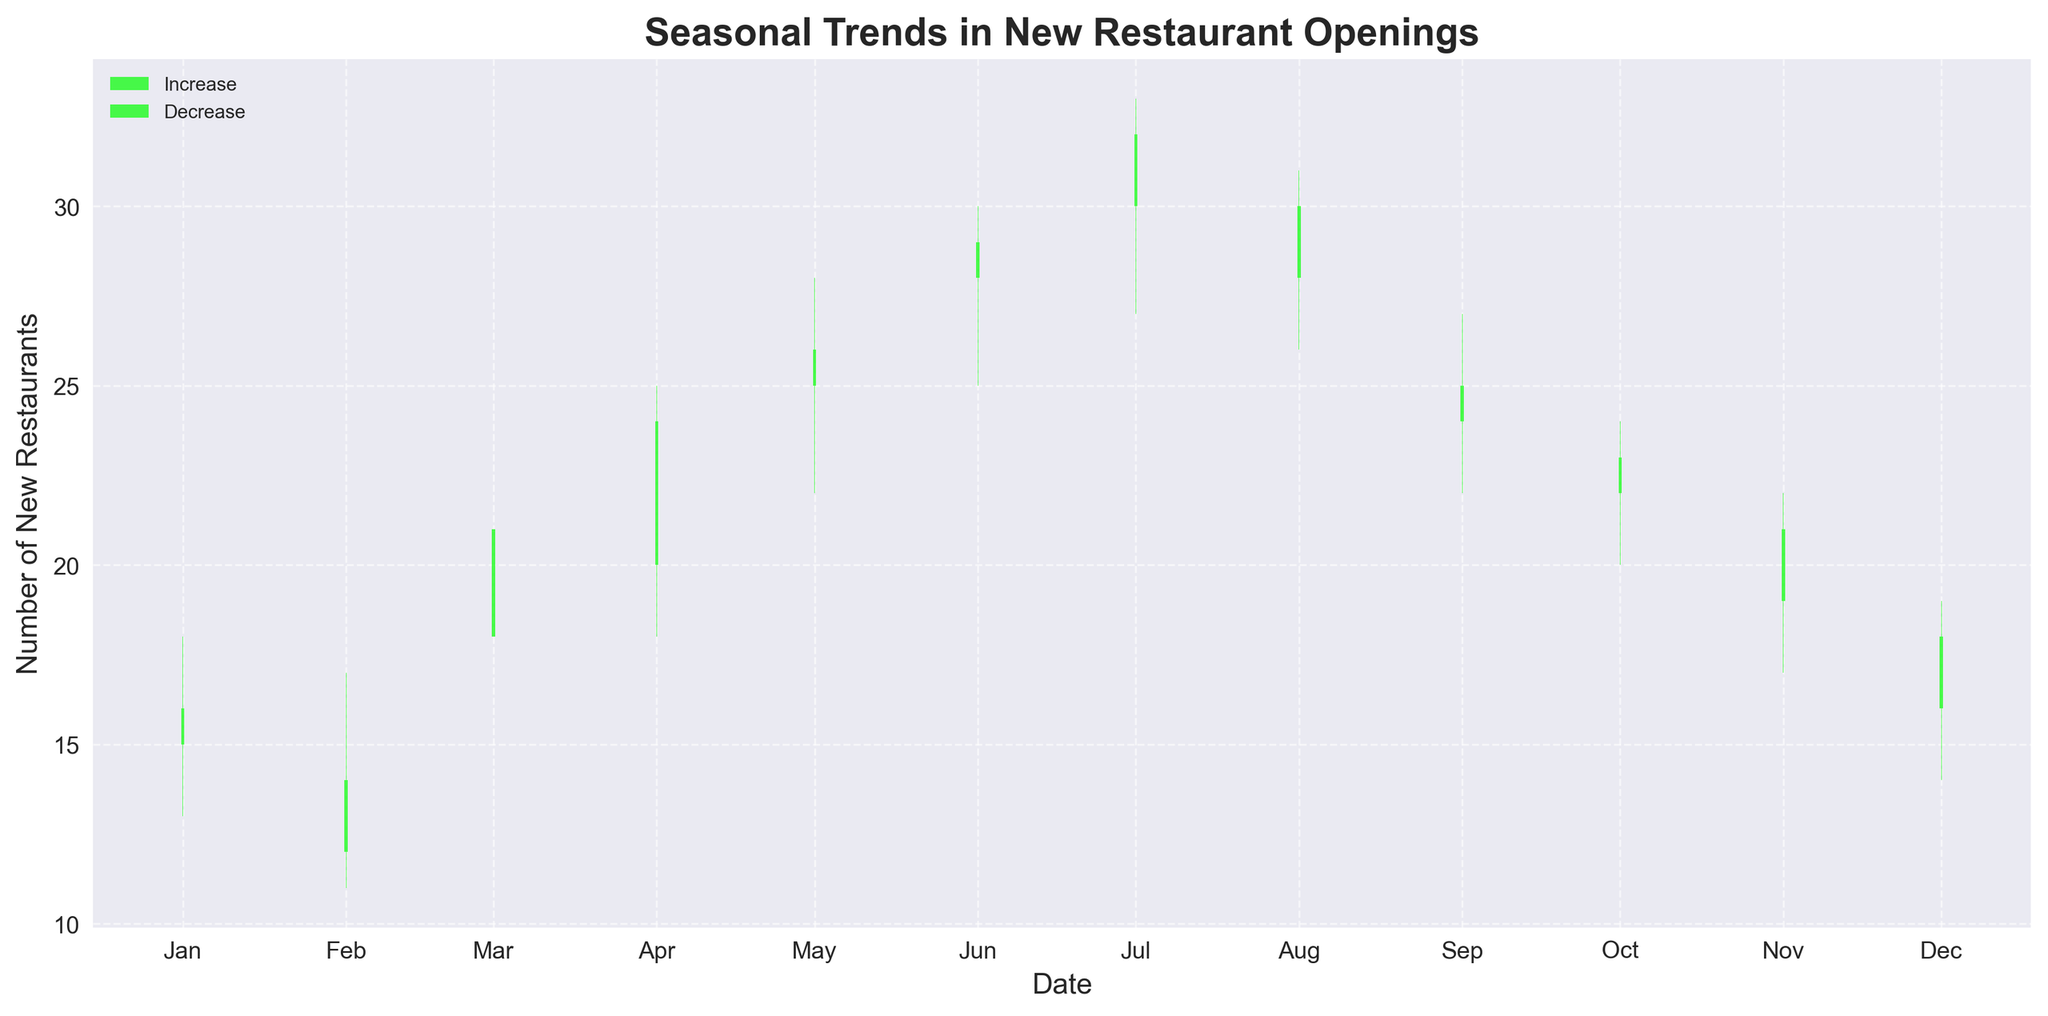What is the title of the figure? The title is displayed at the top of the figure, indicating what the plot represents.
Answer: Seasonal Trends in New Restaurant Openings How many months have an increase in the number of new restaurants compared to the previous month? Count the green candlesticks where the closing value is higher than the opening value. These months show an increase.
Answer: 5 Which month had the highest number of new restaurant openings? Observe the candlestick with the highest 'High' value across all months.
Answer: July What is the lowest number of new restaurant openings in the given data? Find the candlestick with the lowest 'Low' value across all months.
Answer: 11 (February) Which month showed a decrease in new restaurant openings from June to July? Identify the change in candlestick colors and values between June and July.
Answer: None, July increased from June What is the average number of new restaurant openings across all the months? Sum all the 'Close' values from each month and divide by the number of months (12). (16 + 14 + 21 + 24 + 26 + 29 + 32 + 30 + 25 + 23 + 21 + 18) / 12.
Answer: 23.25 Which month experienced the most considerable change in the number of new restaurants from the previous month? Compare the vertical change in 'Close' values month-to-month and find the largest difference.
Answer: March (7 increase from February to March) During which month did the number of new restaurant openings decrease but then significantly increase the following month? Find a red candlestick followed by a tall green candlestick.
Answer: February to March What is the range of the number of new restaurant openings in May? Subtract the 'Low' value from the 'High' value for May.
Answer: 6 (28 - 22) Which season (Winter, Spring, Summer, Fall) generally saw the highest number of new restaurant openings? Group the months by season and compare the average 'Close' values for each season.
Answer: Summer (Average: June 29, July 32, August 30) Which season (Winter, Spring, Summer, Fall) generally saw the lowest number of new restaurant openings? Group the months by season and compare the average 'Close' values for each season.
Answer: Winter (Average: December 18, January 16, February 14) 